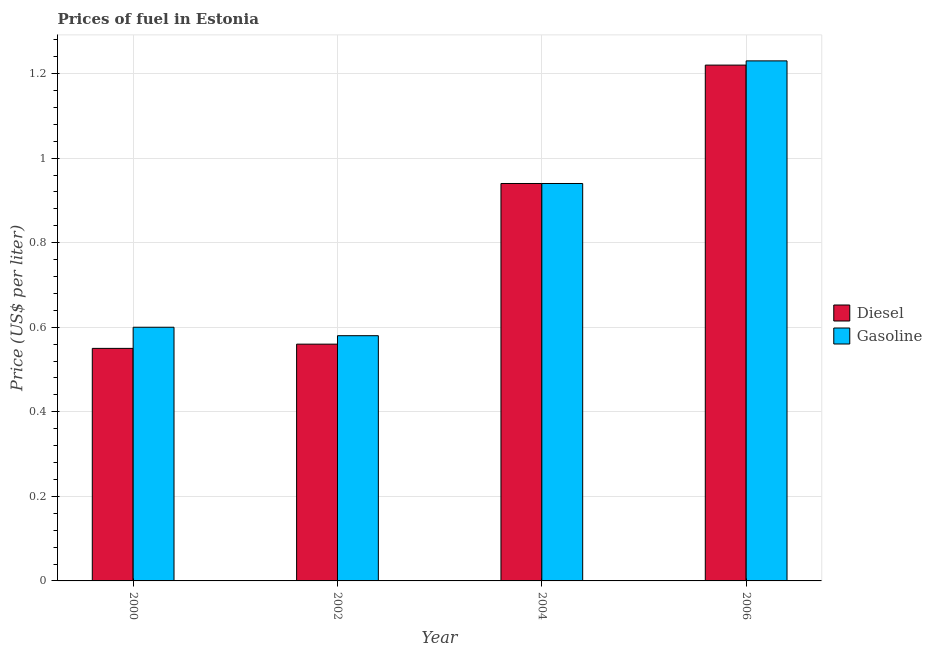How many different coloured bars are there?
Keep it short and to the point. 2. How many groups of bars are there?
Ensure brevity in your answer.  4. Are the number of bars per tick equal to the number of legend labels?
Give a very brief answer. Yes. Are the number of bars on each tick of the X-axis equal?
Make the answer very short. Yes. What is the diesel price in 2000?
Keep it short and to the point. 0.55. Across all years, what is the maximum diesel price?
Ensure brevity in your answer.  1.22. Across all years, what is the minimum gasoline price?
Provide a short and direct response. 0.58. In which year was the gasoline price minimum?
Provide a succinct answer. 2002. What is the total gasoline price in the graph?
Ensure brevity in your answer.  3.35. What is the difference between the gasoline price in 2004 and that in 2006?
Your answer should be very brief. -0.29. What is the difference between the diesel price in 2000 and the gasoline price in 2006?
Your answer should be very brief. -0.67. What is the average gasoline price per year?
Your answer should be compact. 0.84. What is the ratio of the diesel price in 2000 to that in 2002?
Offer a very short reply. 0.98. What is the difference between the highest and the second highest gasoline price?
Provide a succinct answer. 0.29. What is the difference between the highest and the lowest gasoline price?
Your response must be concise. 0.65. In how many years, is the gasoline price greater than the average gasoline price taken over all years?
Make the answer very short. 2. What does the 2nd bar from the left in 2004 represents?
Make the answer very short. Gasoline. What does the 1st bar from the right in 2002 represents?
Keep it short and to the point. Gasoline. How many bars are there?
Ensure brevity in your answer.  8. Are all the bars in the graph horizontal?
Provide a succinct answer. No. How many years are there in the graph?
Give a very brief answer. 4. Are the values on the major ticks of Y-axis written in scientific E-notation?
Your response must be concise. No. Does the graph contain any zero values?
Keep it short and to the point. No. How are the legend labels stacked?
Ensure brevity in your answer.  Vertical. What is the title of the graph?
Provide a succinct answer. Prices of fuel in Estonia. What is the label or title of the X-axis?
Give a very brief answer. Year. What is the label or title of the Y-axis?
Offer a terse response. Price (US$ per liter). What is the Price (US$ per liter) of Diesel in 2000?
Provide a short and direct response. 0.55. What is the Price (US$ per liter) in Diesel in 2002?
Your response must be concise. 0.56. What is the Price (US$ per liter) in Gasoline in 2002?
Keep it short and to the point. 0.58. What is the Price (US$ per liter) of Diesel in 2004?
Offer a terse response. 0.94. What is the Price (US$ per liter) of Diesel in 2006?
Ensure brevity in your answer.  1.22. What is the Price (US$ per liter) in Gasoline in 2006?
Provide a short and direct response. 1.23. Across all years, what is the maximum Price (US$ per liter) in Diesel?
Your answer should be very brief. 1.22. Across all years, what is the maximum Price (US$ per liter) in Gasoline?
Make the answer very short. 1.23. Across all years, what is the minimum Price (US$ per liter) in Diesel?
Ensure brevity in your answer.  0.55. Across all years, what is the minimum Price (US$ per liter) in Gasoline?
Offer a terse response. 0.58. What is the total Price (US$ per liter) in Diesel in the graph?
Your answer should be compact. 3.27. What is the total Price (US$ per liter) in Gasoline in the graph?
Give a very brief answer. 3.35. What is the difference between the Price (US$ per liter) in Diesel in 2000 and that in 2002?
Keep it short and to the point. -0.01. What is the difference between the Price (US$ per liter) in Diesel in 2000 and that in 2004?
Your response must be concise. -0.39. What is the difference between the Price (US$ per liter) of Gasoline in 2000 and that in 2004?
Provide a short and direct response. -0.34. What is the difference between the Price (US$ per liter) of Diesel in 2000 and that in 2006?
Make the answer very short. -0.67. What is the difference between the Price (US$ per liter) of Gasoline in 2000 and that in 2006?
Your response must be concise. -0.63. What is the difference between the Price (US$ per liter) of Diesel in 2002 and that in 2004?
Provide a succinct answer. -0.38. What is the difference between the Price (US$ per liter) in Gasoline in 2002 and that in 2004?
Your answer should be compact. -0.36. What is the difference between the Price (US$ per liter) in Diesel in 2002 and that in 2006?
Your answer should be compact. -0.66. What is the difference between the Price (US$ per liter) in Gasoline in 2002 and that in 2006?
Your response must be concise. -0.65. What is the difference between the Price (US$ per liter) of Diesel in 2004 and that in 2006?
Give a very brief answer. -0.28. What is the difference between the Price (US$ per liter) in Gasoline in 2004 and that in 2006?
Make the answer very short. -0.29. What is the difference between the Price (US$ per liter) of Diesel in 2000 and the Price (US$ per liter) of Gasoline in 2002?
Keep it short and to the point. -0.03. What is the difference between the Price (US$ per liter) of Diesel in 2000 and the Price (US$ per liter) of Gasoline in 2004?
Make the answer very short. -0.39. What is the difference between the Price (US$ per liter) of Diesel in 2000 and the Price (US$ per liter) of Gasoline in 2006?
Your answer should be compact. -0.68. What is the difference between the Price (US$ per liter) of Diesel in 2002 and the Price (US$ per liter) of Gasoline in 2004?
Offer a very short reply. -0.38. What is the difference between the Price (US$ per liter) in Diesel in 2002 and the Price (US$ per liter) in Gasoline in 2006?
Provide a short and direct response. -0.67. What is the difference between the Price (US$ per liter) in Diesel in 2004 and the Price (US$ per liter) in Gasoline in 2006?
Provide a succinct answer. -0.29. What is the average Price (US$ per liter) in Diesel per year?
Make the answer very short. 0.82. What is the average Price (US$ per liter) in Gasoline per year?
Your answer should be very brief. 0.84. In the year 2002, what is the difference between the Price (US$ per liter) in Diesel and Price (US$ per liter) in Gasoline?
Your response must be concise. -0.02. In the year 2004, what is the difference between the Price (US$ per liter) in Diesel and Price (US$ per liter) in Gasoline?
Provide a short and direct response. 0. In the year 2006, what is the difference between the Price (US$ per liter) of Diesel and Price (US$ per liter) of Gasoline?
Your response must be concise. -0.01. What is the ratio of the Price (US$ per liter) of Diesel in 2000 to that in 2002?
Offer a terse response. 0.98. What is the ratio of the Price (US$ per liter) of Gasoline in 2000 to that in 2002?
Offer a very short reply. 1.03. What is the ratio of the Price (US$ per liter) of Diesel in 2000 to that in 2004?
Give a very brief answer. 0.59. What is the ratio of the Price (US$ per liter) of Gasoline in 2000 to that in 2004?
Your answer should be compact. 0.64. What is the ratio of the Price (US$ per liter) in Diesel in 2000 to that in 2006?
Keep it short and to the point. 0.45. What is the ratio of the Price (US$ per liter) of Gasoline in 2000 to that in 2006?
Offer a very short reply. 0.49. What is the ratio of the Price (US$ per liter) in Diesel in 2002 to that in 2004?
Make the answer very short. 0.6. What is the ratio of the Price (US$ per liter) of Gasoline in 2002 to that in 2004?
Your answer should be very brief. 0.62. What is the ratio of the Price (US$ per liter) of Diesel in 2002 to that in 2006?
Make the answer very short. 0.46. What is the ratio of the Price (US$ per liter) in Gasoline in 2002 to that in 2006?
Make the answer very short. 0.47. What is the ratio of the Price (US$ per liter) of Diesel in 2004 to that in 2006?
Give a very brief answer. 0.77. What is the ratio of the Price (US$ per liter) in Gasoline in 2004 to that in 2006?
Provide a short and direct response. 0.76. What is the difference between the highest and the second highest Price (US$ per liter) of Diesel?
Your answer should be compact. 0.28. What is the difference between the highest and the second highest Price (US$ per liter) of Gasoline?
Your response must be concise. 0.29. What is the difference between the highest and the lowest Price (US$ per liter) of Diesel?
Keep it short and to the point. 0.67. What is the difference between the highest and the lowest Price (US$ per liter) in Gasoline?
Offer a very short reply. 0.65. 